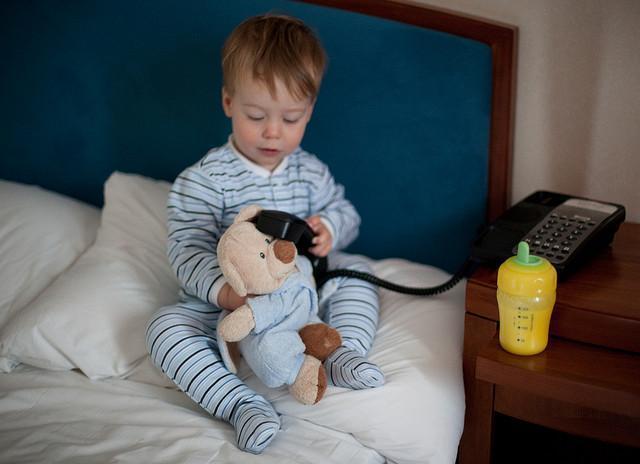How many teddy bears are in the photo?
Give a very brief answer. 2. How many people are in the photo?
Give a very brief answer. 1. 